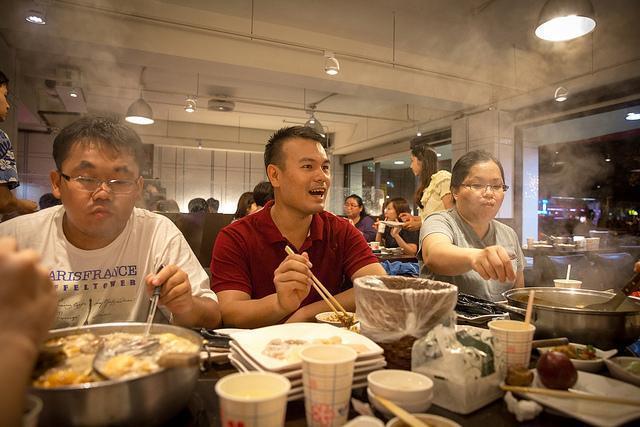How many cups are in this photo?
Give a very brief answer. 4. How many cups are there?
Give a very brief answer. 2. How many bowls are visible?
Give a very brief answer. 3. How many people are there?
Give a very brief answer. 5. 